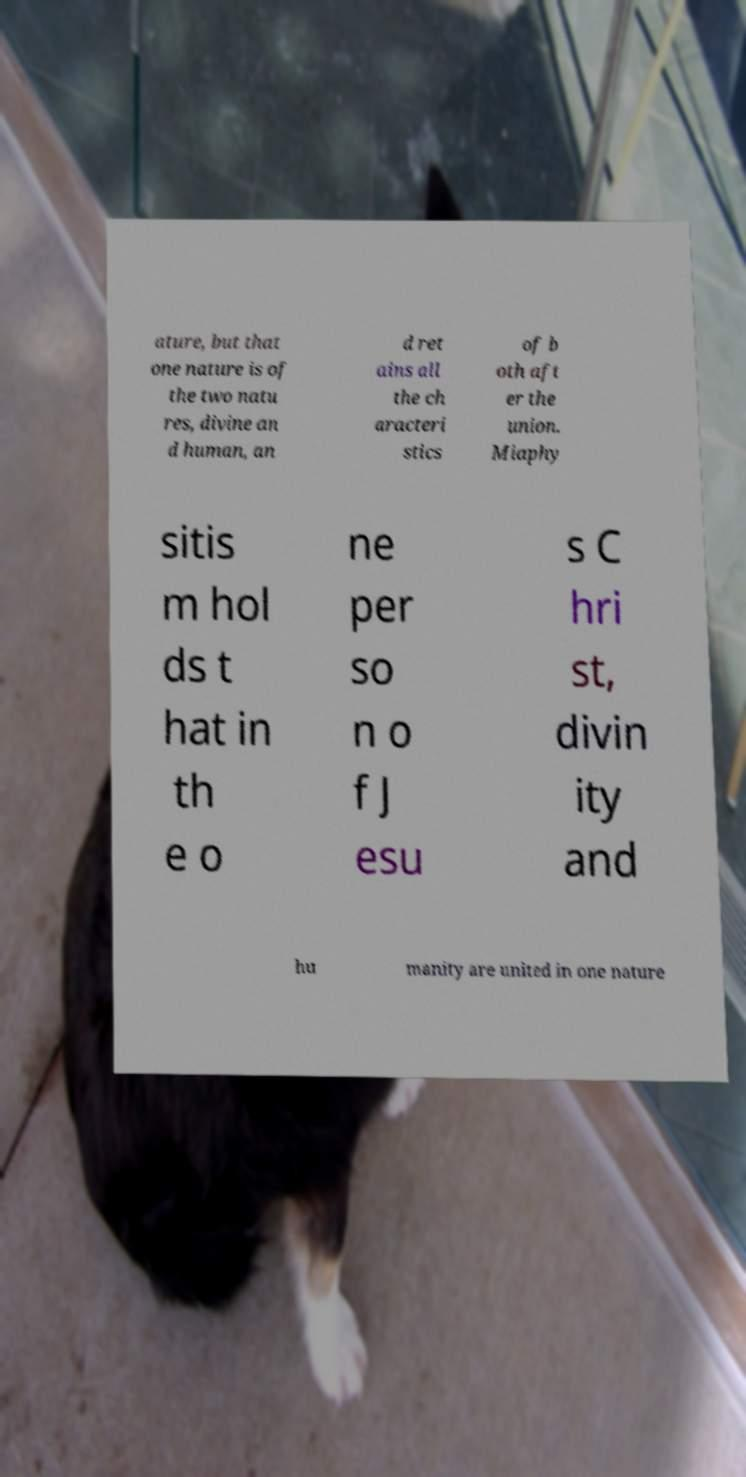Can you read and provide the text displayed in the image?This photo seems to have some interesting text. Can you extract and type it out for me? ature, but that one nature is of the two natu res, divine an d human, an d ret ains all the ch aracteri stics of b oth aft er the union. Miaphy sitis m hol ds t hat in th e o ne per so n o f J esu s C hri st, divin ity and hu manity are united in one nature 